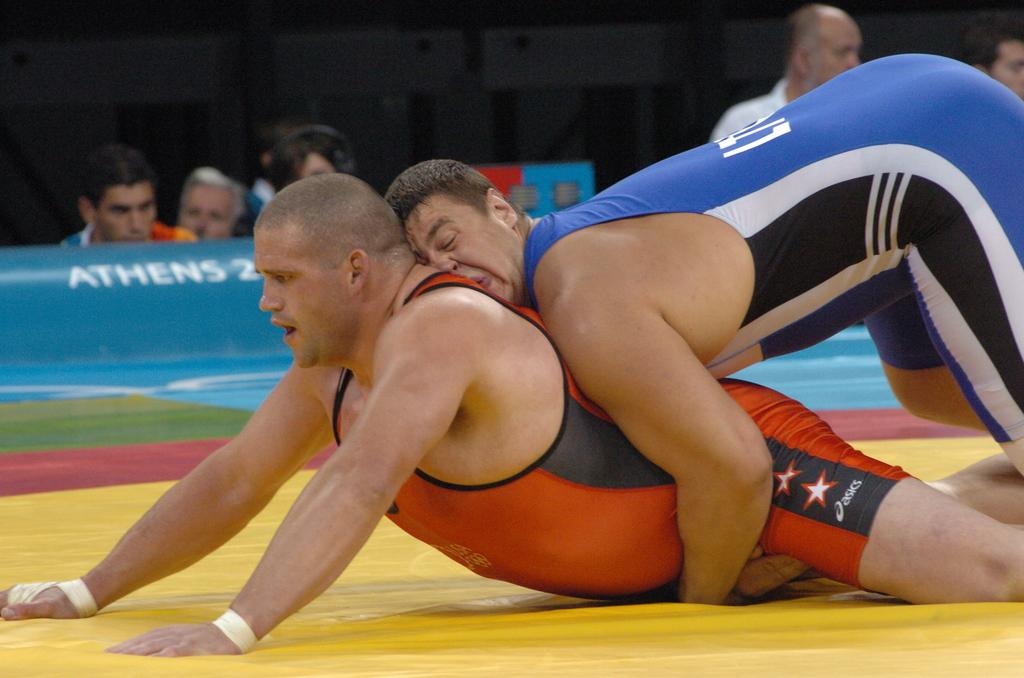<image>
Describe the image concisely. Two wrestlers are on the mat wit hthe wrestler in red having the Asics logo on his leg. 